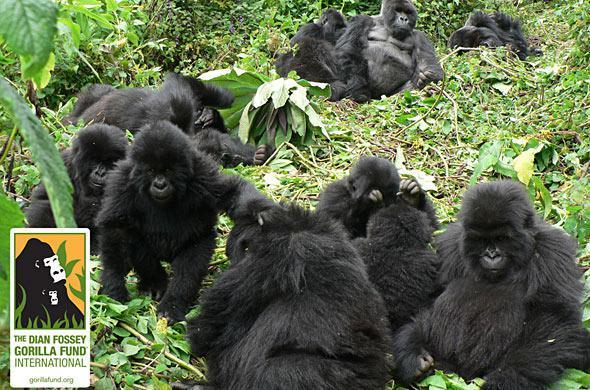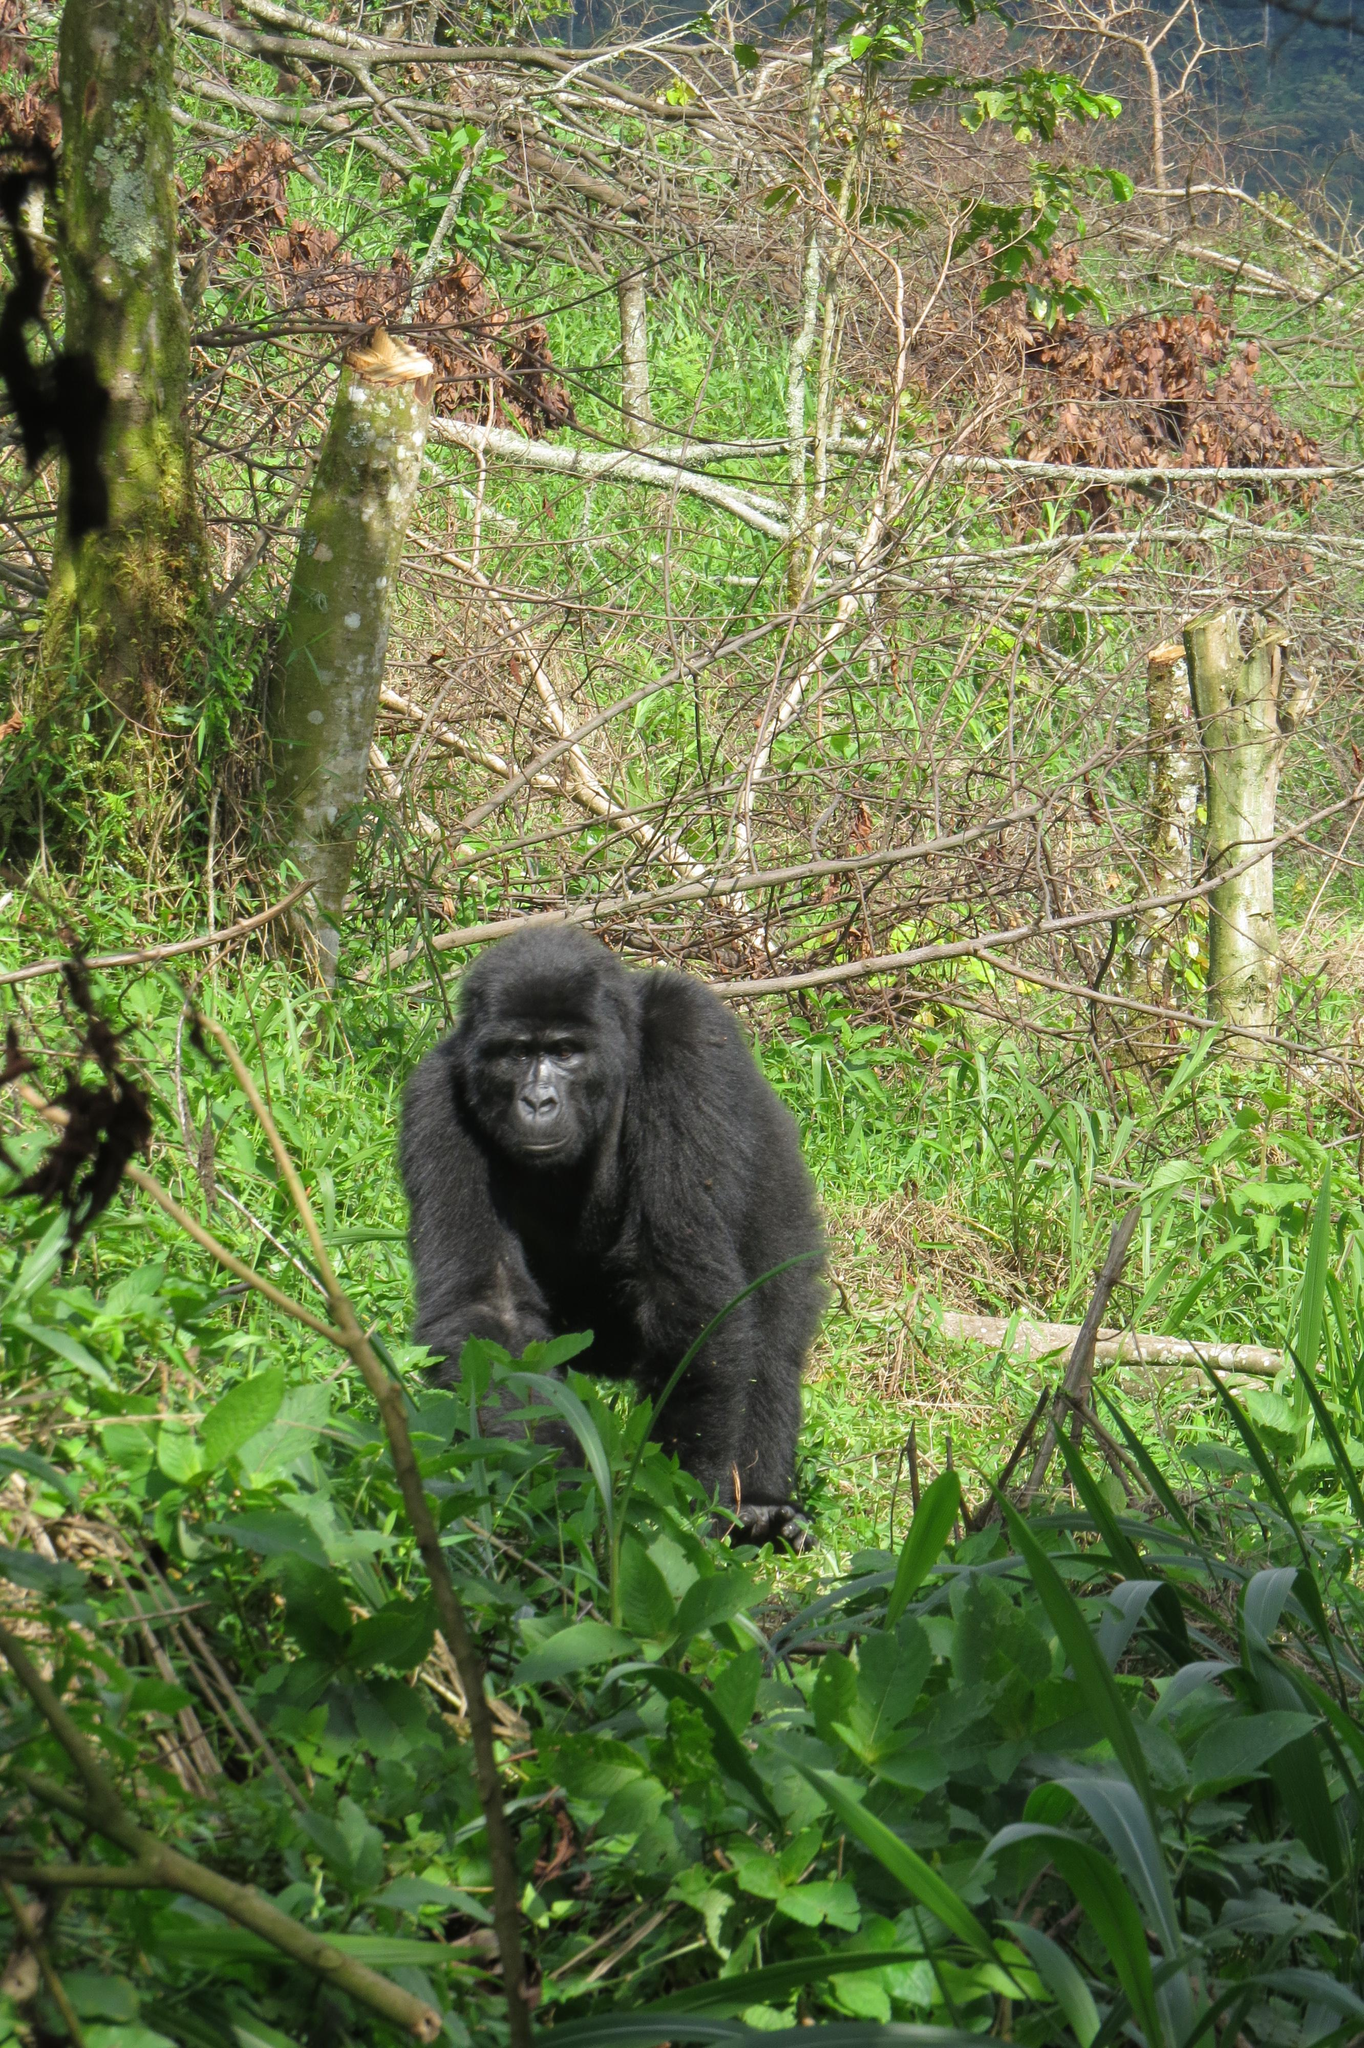The first image is the image on the left, the second image is the image on the right. Considering the images on both sides, is "There are no more than four monkeys." valid? Answer yes or no. No. 